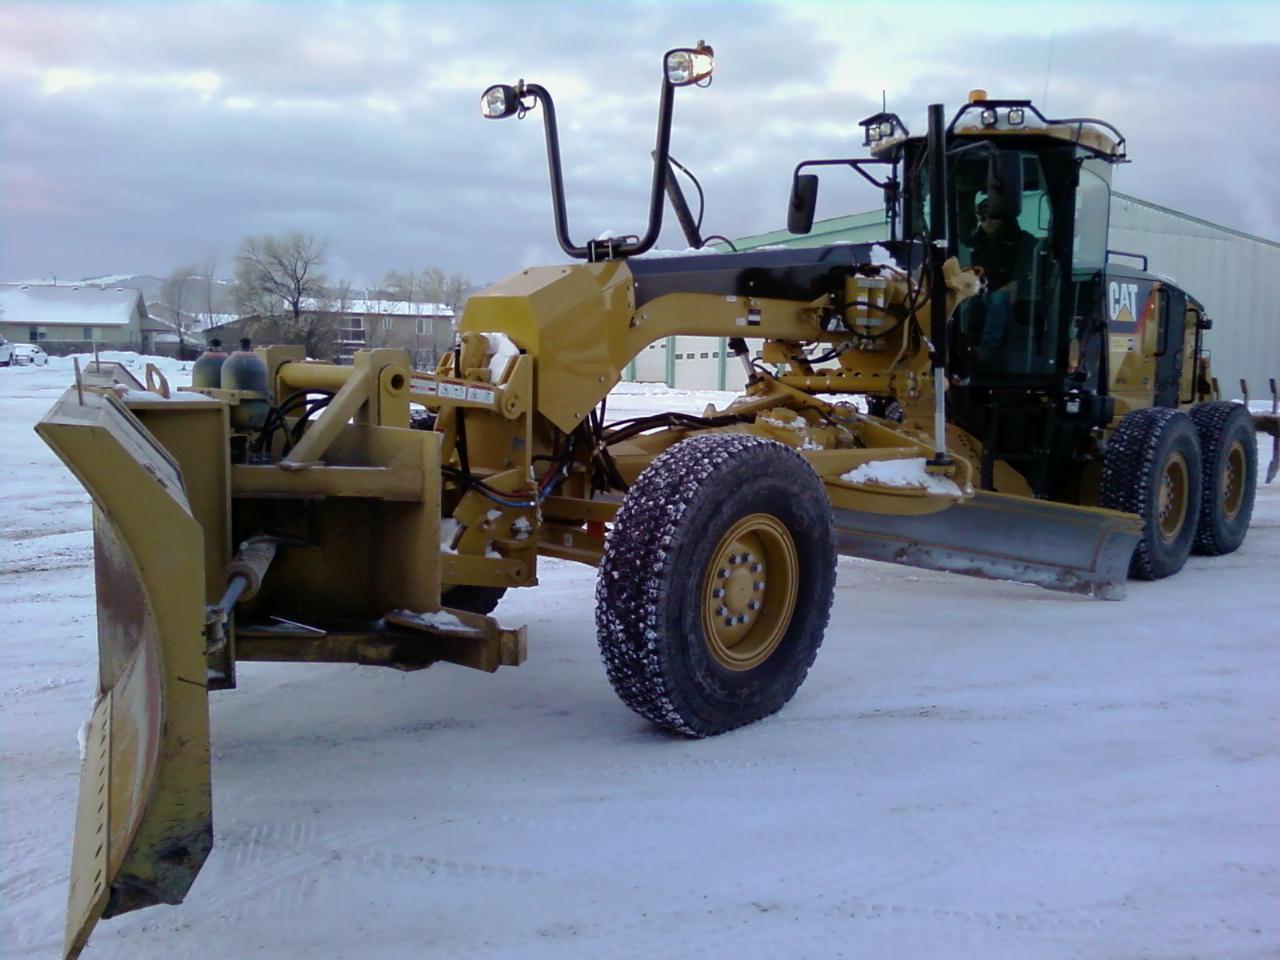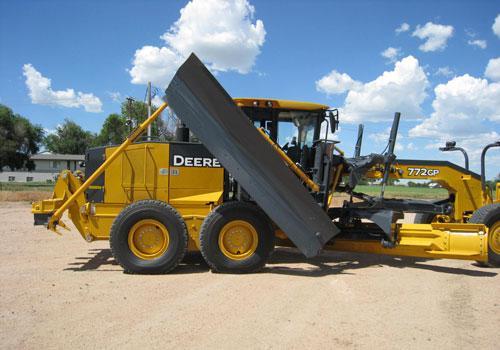The first image is the image on the left, the second image is the image on the right. For the images shown, is this caption "The lights in the image on the left are mounted on a handlebar shaped mount." true? Answer yes or no. Yes. The first image is the image on the left, the second image is the image on the right. Considering the images on both sides, is "Right image shows at least one yellow tractor with plow on a dirt ground without snow." valid? Answer yes or no. Yes. 